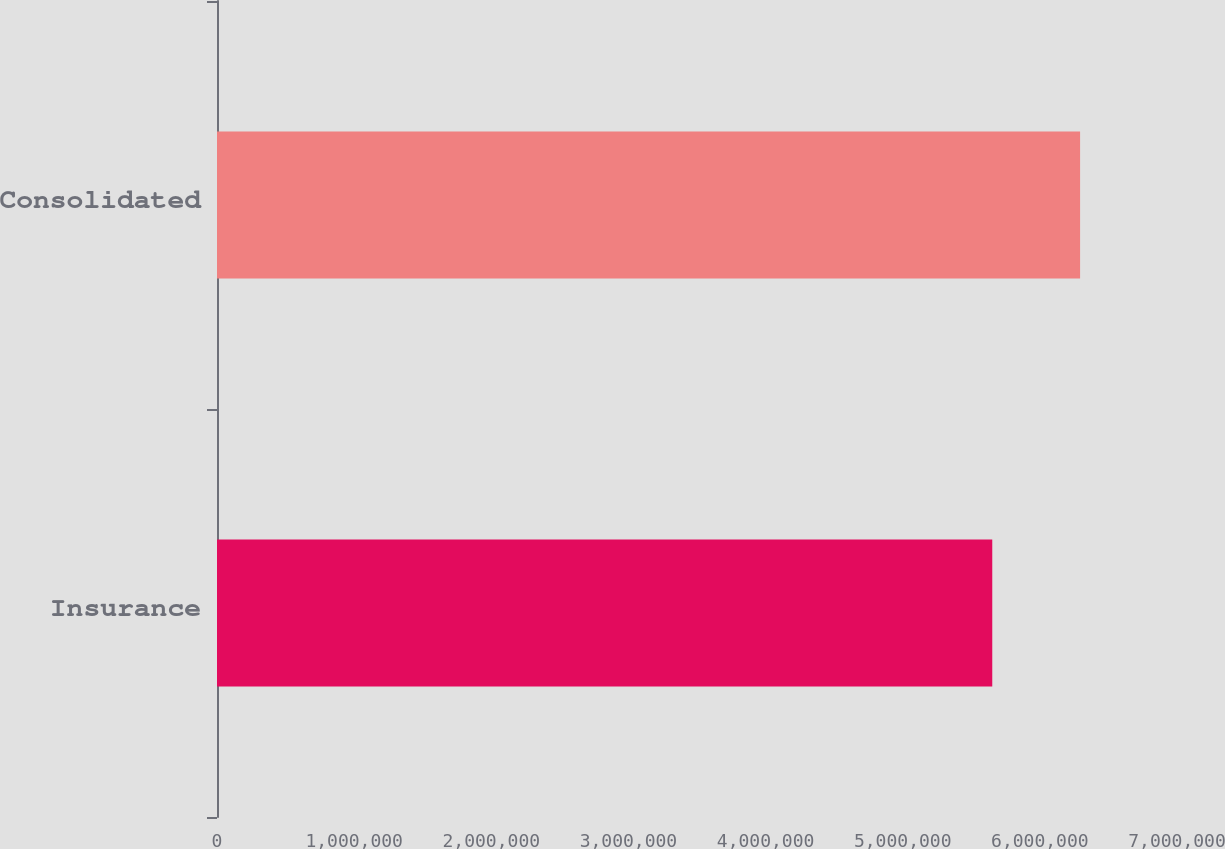Convert chart. <chart><loc_0><loc_0><loc_500><loc_500><bar_chart><fcel>Insurance<fcel>Consolidated<nl><fcel>5.6529e+06<fcel>6.29335e+06<nl></chart> 